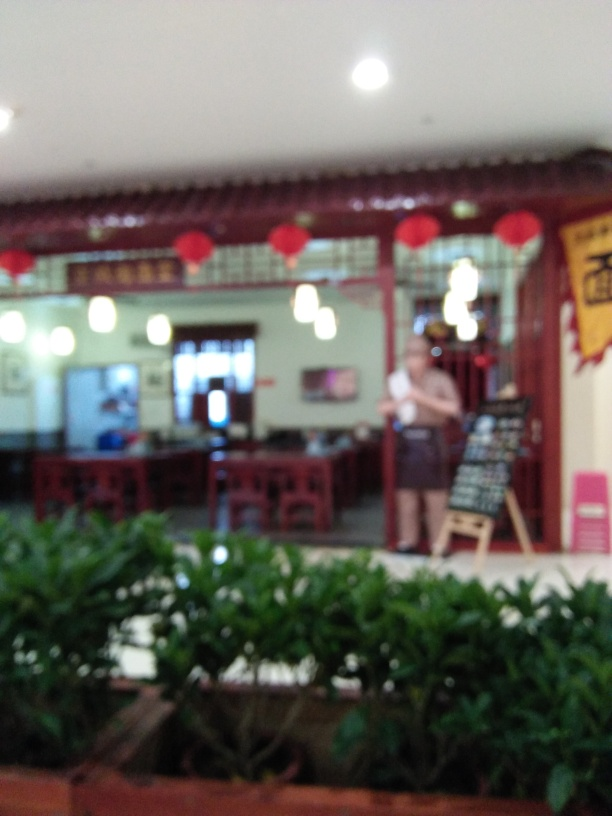What kind of establishment does this image depict? The image suggests an interior view of a dining establishment, possibly a restaurant. The presence of tables, chairs, and festive red lanterns implies a place where people can sit and enjoy meals. Additionally, the traditional-style furniture hints at a specific cultural theme. 